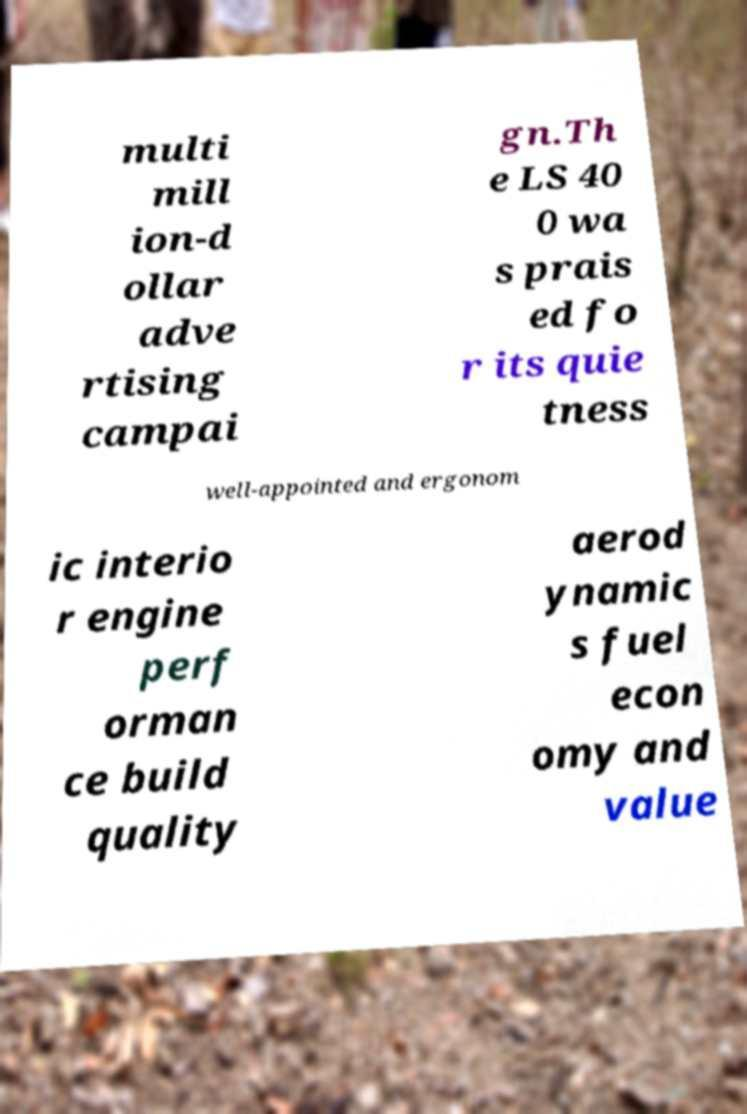Could you assist in decoding the text presented in this image and type it out clearly? multi mill ion-d ollar adve rtising campai gn.Th e LS 40 0 wa s prais ed fo r its quie tness well-appointed and ergonom ic interio r engine perf orman ce build quality aerod ynamic s fuel econ omy and value 